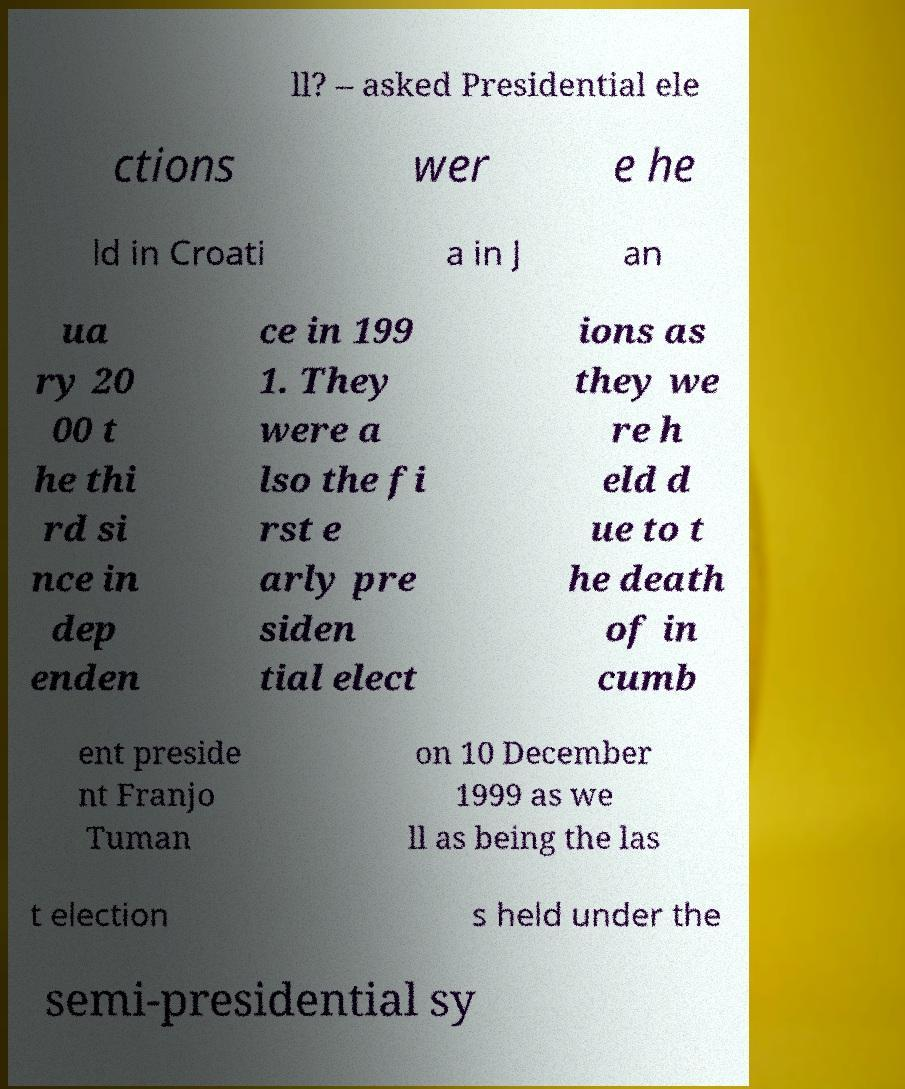Can you read and provide the text displayed in the image?This photo seems to have some interesting text. Can you extract and type it out for me? ll? – asked Presidential ele ctions wer e he ld in Croati a in J an ua ry 20 00 t he thi rd si nce in dep enden ce in 199 1. They were a lso the fi rst e arly pre siden tial elect ions as they we re h eld d ue to t he death of in cumb ent preside nt Franjo Tuman on 10 December 1999 as we ll as being the las t election s held under the semi-presidential sy 